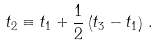<formula> <loc_0><loc_0><loc_500><loc_500>t _ { 2 } \equiv t _ { 1 } + \frac { 1 } { 2 } \left ( t _ { 3 } - t _ { 1 } \right ) \, .</formula> 